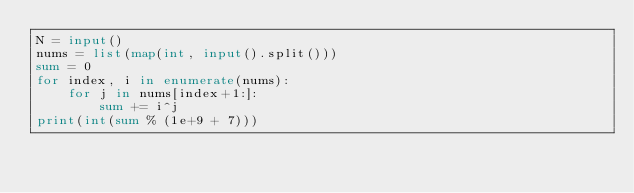<code> <loc_0><loc_0><loc_500><loc_500><_Python_>N = input()
nums = list(map(int, input().split()))
sum = 0
for index, i in enumerate(nums):
    for j in nums[index+1:]:
        sum += i^j
print(int(sum % (1e+9 + 7)))
</code> 